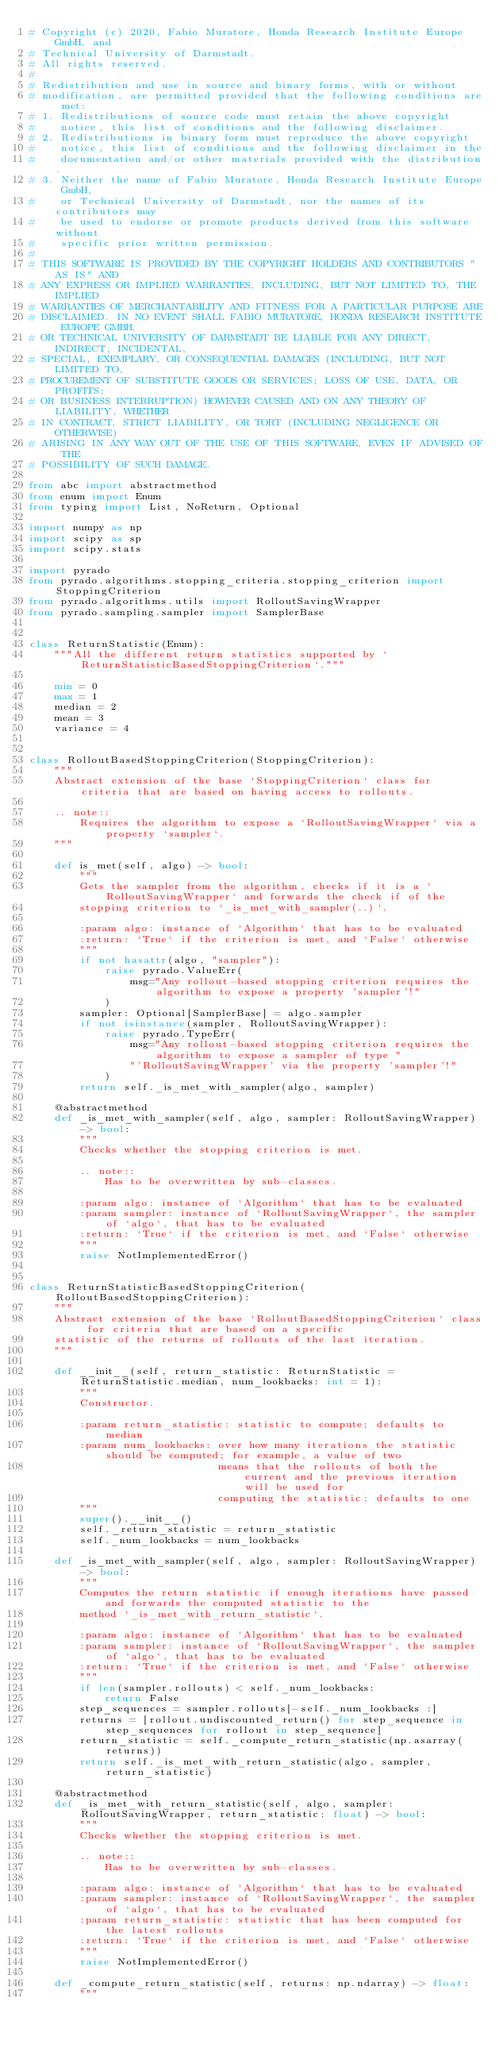<code> <loc_0><loc_0><loc_500><loc_500><_Python_># Copyright (c) 2020, Fabio Muratore, Honda Research Institute Europe GmbH, and
# Technical University of Darmstadt.
# All rights reserved.
#
# Redistribution and use in source and binary forms, with or without
# modification, are permitted provided that the following conditions are met:
# 1. Redistributions of source code must retain the above copyright
#    notice, this list of conditions and the following disclaimer.
# 2. Redistributions in binary form must reproduce the above copyright
#    notice, this list of conditions and the following disclaimer in the
#    documentation and/or other materials provided with the distribution.
# 3. Neither the name of Fabio Muratore, Honda Research Institute Europe GmbH,
#    or Technical University of Darmstadt, nor the names of its contributors may
#    be used to endorse or promote products derived from this software without
#    specific prior written permission.
#
# THIS SOFTWARE IS PROVIDED BY THE COPYRIGHT HOLDERS AND CONTRIBUTORS "AS IS" AND
# ANY EXPRESS OR IMPLIED WARRANTIES, INCLUDING, BUT NOT LIMITED TO, THE IMPLIED
# WARRANTIES OF MERCHANTABILITY AND FITNESS FOR A PARTICULAR PURPOSE ARE
# DISCLAIMED. IN NO EVENT SHALL FABIO MURATORE, HONDA RESEARCH INSTITUTE EUROPE GMBH,
# OR TECHNICAL UNIVERSITY OF DARMSTADT BE LIABLE FOR ANY DIRECT, INDIRECT, INCIDENTAL,
# SPECIAL, EXEMPLARY, OR CONSEQUENTIAL DAMAGES (INCLUDING, BUT NOT LIMITED TO,
# PROCUREMENT OF SUBSTITUTE GOODS OR SERVICES; LOSS OF USE, DATA, OR PROFITS;
# OR BUSINESS INTERRUPTION) HOWEVER CAUSED AND ON ANY THEORY OF LIABILITY, WHETHER
# IN CONTRACT, STRICT LIABILITY, OR TORT (INCLUDING NEGLIGENCE OR OTHERWISE)
# ARISING IN ANY WAY OUT OF THE USE OF THIS SOFTWARE, EVEN IF ADVISED OF THE
# POSSIBILITY OF SUCH DAMAGE.

from abc import abstractmethod
from enum import Enum
from typing import List, NoReturn, Optional

import numpy as np
import scipy as sp
import scipy.stats

import pyrado
from pyrado.algorithms.stopping_criteria.stopping_criterion import StoppingCriterion
from pyrado.algorithms.utils import RolloutSavingWrapper
from pyrado.sampling.sampler import SamplerBase


class ReturnStatistic(Enum):
    """All the different return statistics supported by `ReturnStatisticBasedStoppingCriterion`."""

    min = 0
    max = 1
    median = 2
    mean = 3
    variance = 4


class RolloutBasedStoppingCriterion(StoppingCriterion):
    """
    Abstract extension of the base `StoppingCriterion` class for criteria that are based on having access to rollouts.

    .. note::
        Requires the algorithm to expose a `RolloutSavingWrapper` via a property `sampler`.
    """

    def is_met(self, algo) -> bool:
        """
        Gets the sampler from the algorithm, checks if it is a `RolloutSavingWrapper` and forwards the check if of the
        stopping criterion to `_is_met_with_sampler(..)`.

        :param algo: instance of `Algorithm` that has to be evaluated
        :return: `True` if the criterion is met, and `False` otherwise
        """
        if not hasattr(algo, "sampler"):
            raise pyrado.ValueErr(
                msg="Any rollout-based stopping criterion requires the algorithm to expose a property 'sampler'!"
            )
        sampler: Optional[SamplerBase] = algo.sampler
        if not isinstance(sampler, RolloutSavingWrapper):
            raise pyrado.TypeErr(
                msg="Any rollout-based stopping criterion requires the algorithm to expose a sampler of type "
                "'RolloutSavingWrapper' via the property 'sampler'!"
            )
        return self._is_met_with_sampler(algo, sampler)

    @abstractmethod
    def _is_met_with_sampler(self, algo, sampler: RolloutSavingWrapper) -> bool:
        """
        Checks whether the stopping criterion is met.

        .. note::
            Has to be overwritten by sub-classes.

        :param algo: instance of `Algorithm` that has to be evaluated
        :param sampler: instance of `RolloutSavingWrapper`, the sampler of `algo`, that has to be evaluated
        :return: `True` if the criterion is met, and `False` otherwise
        """
        raise NotImplementedError()


class ReturnStatisticBasedStoppingCriterion(RolloutBasedStoppingCriterion):
    """
    Abstract extension of the base `RolloutBasedStoppingCriterion` class for criteria that are based on a specific
    statistic of the returns of rollouts of the last iteration.
    """

    def __init__(self, return_statistic: ReturnStatistic = ReturnStatistic.median, num_lookbacks: int = 1):
        """
        Constructor.

        :param return_statistic: statistic to compute; defaults to median
        :param num_lookbacks: over how many iterations the statistic should be computed; for example, a value of two
                              means that the rollouts of both the current and the previous iteration will be used for
                              computing the statistic; defaults to one
        """
        super().__init__()
        self._return_statistic = return_statistic
        self._num_lookbacks = num_lookbacks

    def _is_met_with_sampler(self, algo, sampler: RolloutSavingWrapper) -> bool:
        """
        Computes the return statistic if enough iterations have passed and forwards the computed statistic to the
        method `_is_met_with_return_statistic`.

        :param algo: instance of `Algorithm` that has to be evaluated
        :param sampler: instance of `RolloutSavingWrapper`, the sampler of `algo`, that has to be evaluated
        :return: `True` if the criterion is met, and `False` otherwise
        """
        if len(sampler.rollouts) < self._num_lookbacks:
            return False
        step_sequences = sampler.rollouts[-self._num_lookbacks :]
        returns = [rollout.undiscounted_return() for step_sequence in step_sequences for rollout in step_sequence]
        return_statistic = self._compute_return_statistic(np.asarray(returns))
        return self._is_met_with_return_statistic(algo, sampler, return_statistic)

    @abstractmethod
    def _is_met_with_return_statistic(self, algo, sampler: RolloutSavingWrapper, return_statistic: float) -> bool:
        """
        Checks whether the stopping criterion is met.

        .. note::
            Has to be overwritten by sub-classes.

        :param algo: instance of `Algorithm` that has to be evaluated
        :param sampler: instance of `RolloutSavingWrapper`, the sampler of `algo`, that has to be evaluated
        :param return_statistic: statistic that has been computed for the latest rollouts
        :return: `True` if the criterion is met, and `False` otherwise
        """
        raise NotImplementedError()

    def _compute_return_statistic(self, returns: np.ndarray) -> float:
        """</code> 